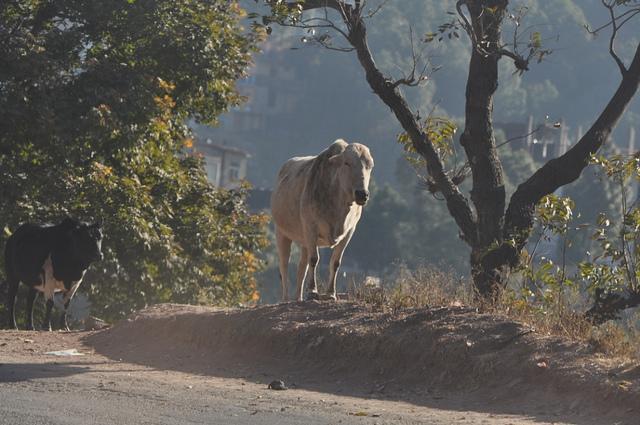How many animals?
Give a very brief answer. 2. How many cows are there?
Give a very brief answer. 2. How many elephants are in the picture?
Give a very brief answer. 0. 